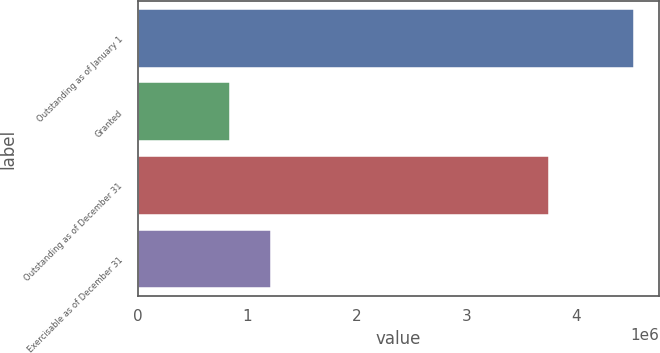<chart> <loc_0><loc_0><loc_500><loc_500><bar_chart><fcel>Outstanding as of January 1<fcel>Granted<fcel>Outstanding as of December 31<fcel>Exercisable as of December 31<nl><fcel>4.53098e+06<fcel>845440<fcel>3.75795e+06<fcel>1.21399e+06<nl></chart> 